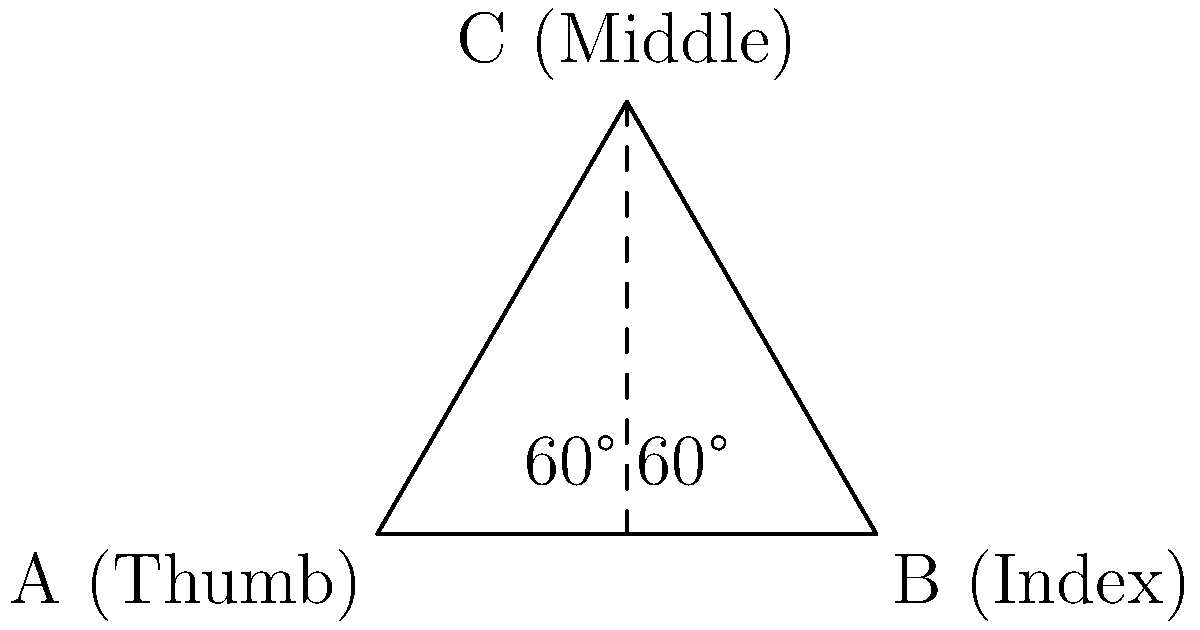During a poetry recitation, a poet forms a triangular hand gesture with their thumb, index, and middle fingers. If the distance between the thumb and index finger is 10 cm, and all angles in the triangle are equal, what is the approximate distance between the thumb and middle finger? To solve this problem, we'll follow these steps:

1. Identify the shape: The hand gesture forms an equilateral triangle (all angles are equal).

2. Recall properties of an equilateral triangle:
   - All angles are 60°
   - All sides are equal in length

3. Given information:
   - Distance between thumb and index finger (AB) = 10 cm
   - This is one side of the equilateral triangle

4. To find the distance between thumb and middle finger (AC), we need to calculate the height of the triangle.

5. In an equilateral triangle, the height (h) is related to the side length (s) by the formula:
   $h = \frac{\sqrt{3}}{2} s$

6. Substituting our known value:
   $h = \frac{\sqrt{3}}{2} \times 10 = 5\sqrt{3}$ cm

7. The distance AC is the hypotenuse of a right triangle formed by half of AB and the height.

8. We can use the Pythagorean theorem to calculate AC:
   $AC^2 = (\frac{AB}{2})^2 + h^2$
   $AC^2 = 5^2 + (5\sqrt{3})^2$
   $AC^2 = 25 + 75 = 100$
   $AC = \sqrt{100} = 10$ cm

Therefore, the distance between the thumb and middle finger is also 10 cm.
Answer: 10 cm 